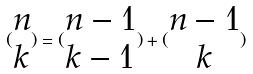Convert formula to latex. <formula><loc_0><loc_0><loc_500><loc_500>( \begin{matrix} n \\ k \end{matrix} ) = ( \begin{matrix} n - 1 \\ k - 1 \end{matrix} ) + ( \begin{matrix} n - 1 \\ k \end{matrix} )</formula> 